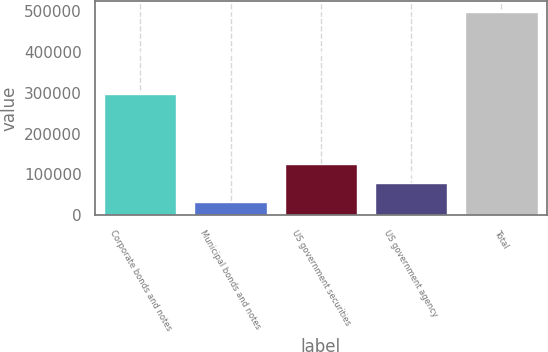<chart> <loc_0><loc_0><loc_500><loc_500><bar_chart><fcel>Corporate bonds and notes<fcel>Municipal bonds and notes<fcel>US government securities<fcel>US government agency<fcel>Total<nl><fcel>298253<fcel>31137<fcel>124823<fcel>77979.8<fcel>499565<nl></chart> 